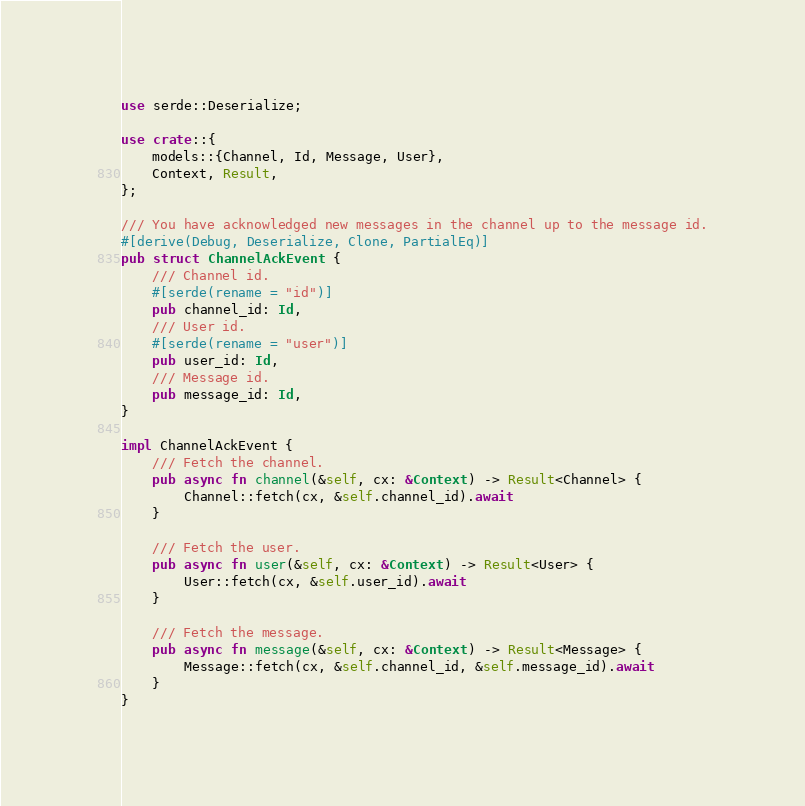Convert code to text. <code><loc_0><loc_0><loc_500><loc_500><_Rust_>use serde::Deserialize;

use crate::{
    models::{Channel, Id, Message, User},
    Context, Result,
};

/// You have acknowledged new messages in the channel up to the message id.
#[derive(Debug, Deserialize, Clone, PartialEq)]
pub struct ChannelAckEvent {
    /// Channel id.
    #[serde(rename = "id")]
    pub channel_id: Id,
    /// User id.
    #[serde(rename = "user")]
    pub user_id: Id,
    /// Message id.
    pub message_id: Id,
}

impl ChannelAckEvent {
    /// Fetch the channel.
    pub async fn channel(&self, cx: &Context) -> Result<Channel> {
        Channel::fetch(cx, &self.channel_id).await
    }

    /// Fetch the user.
    pub async fn user(&self, cx: &Context) -> Result<User> {
        User::fetch(cx, &self.user_id).await
    }

    /// Fetch the message.
    pub async fn message(&self, cx: &Context) -> Result<Message> {
        Message::fetch(cx, &self.channel_id, &self.message_id).await
    }
}
</code> 